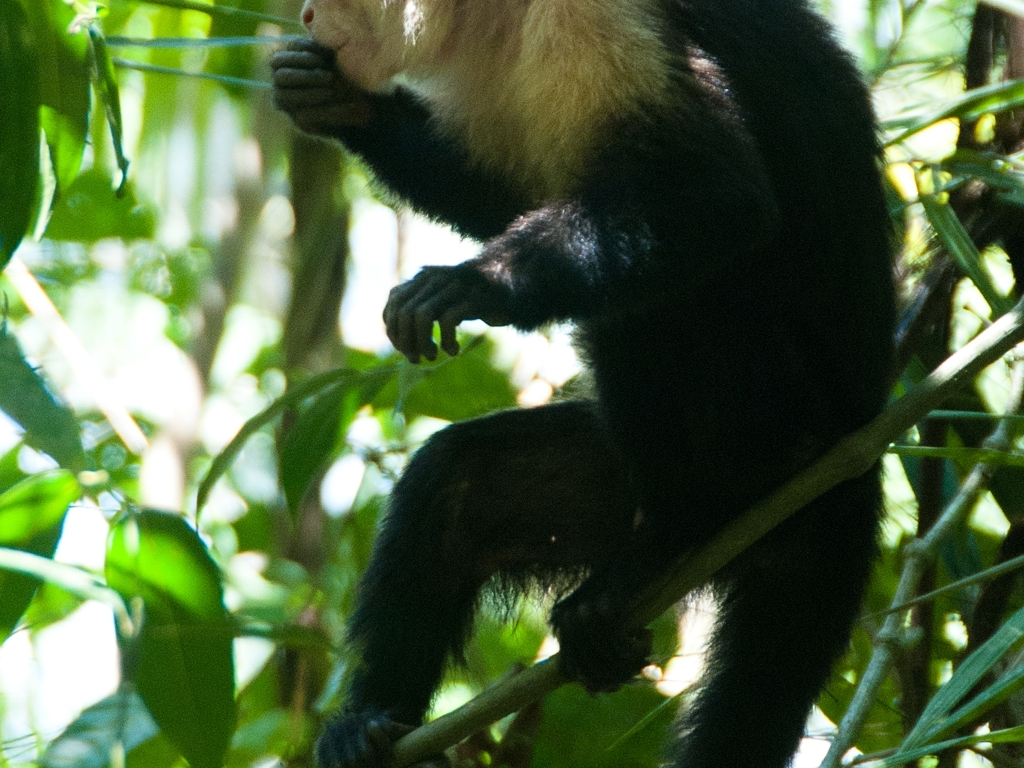Can you describe what the animal is doing and which species it might belong to? The animal appears to be a primate, possibly a monkey, caught in a moment of pause while foraging or traveling through its lush, green arboreal environment. The absence of a clear view of its facial features makes it difficult to determine the exact species. It's holding onto a branch with foliage nearby, suggestive of natural foraging behaviors. 